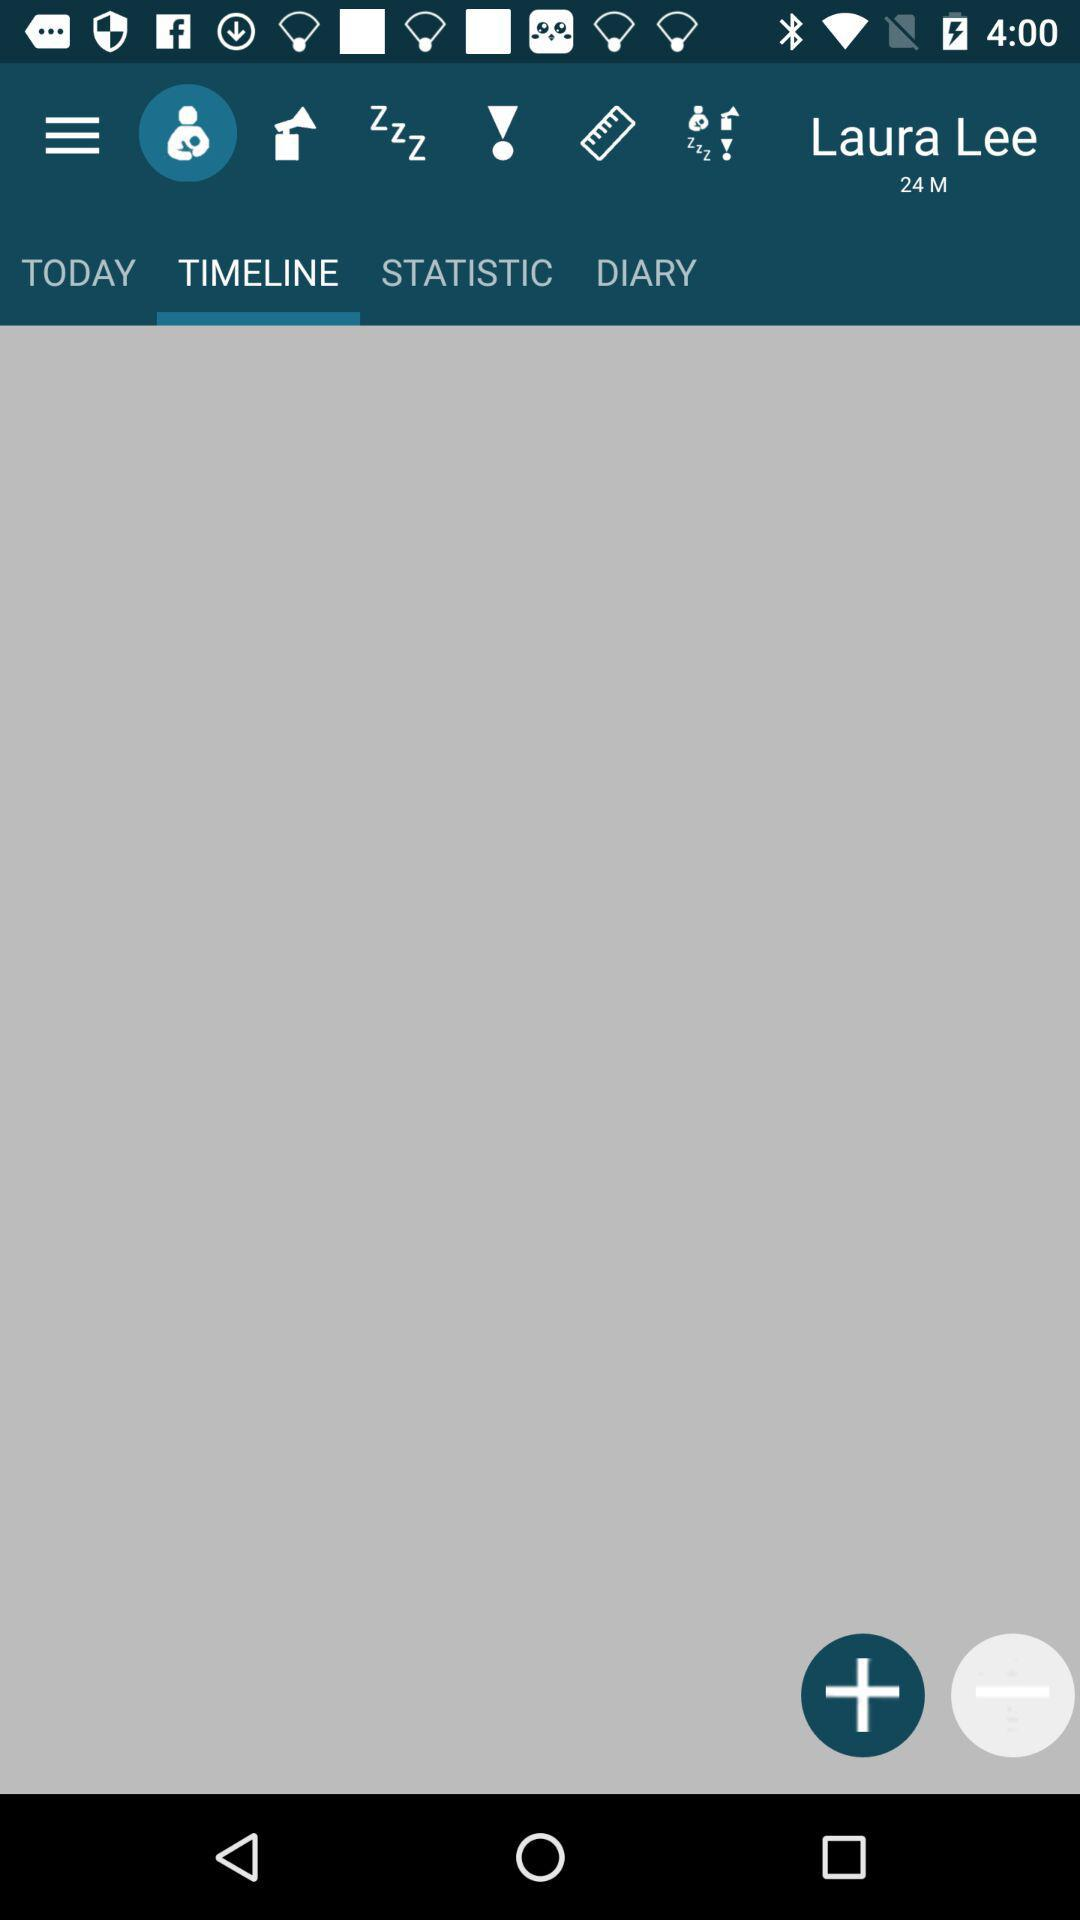Which tab am I on? The tab is "TIMELINE". 